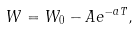<formula> <loc_0><loc_0><loc_500><loc_500>W = W _ { 0 } - A e ^ { - a T } ,</formula> 